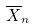Convert formula to latex. <formula><loc_0><loc_0><loc_500><loc_500>\overline { X } _ { n }</formula> 